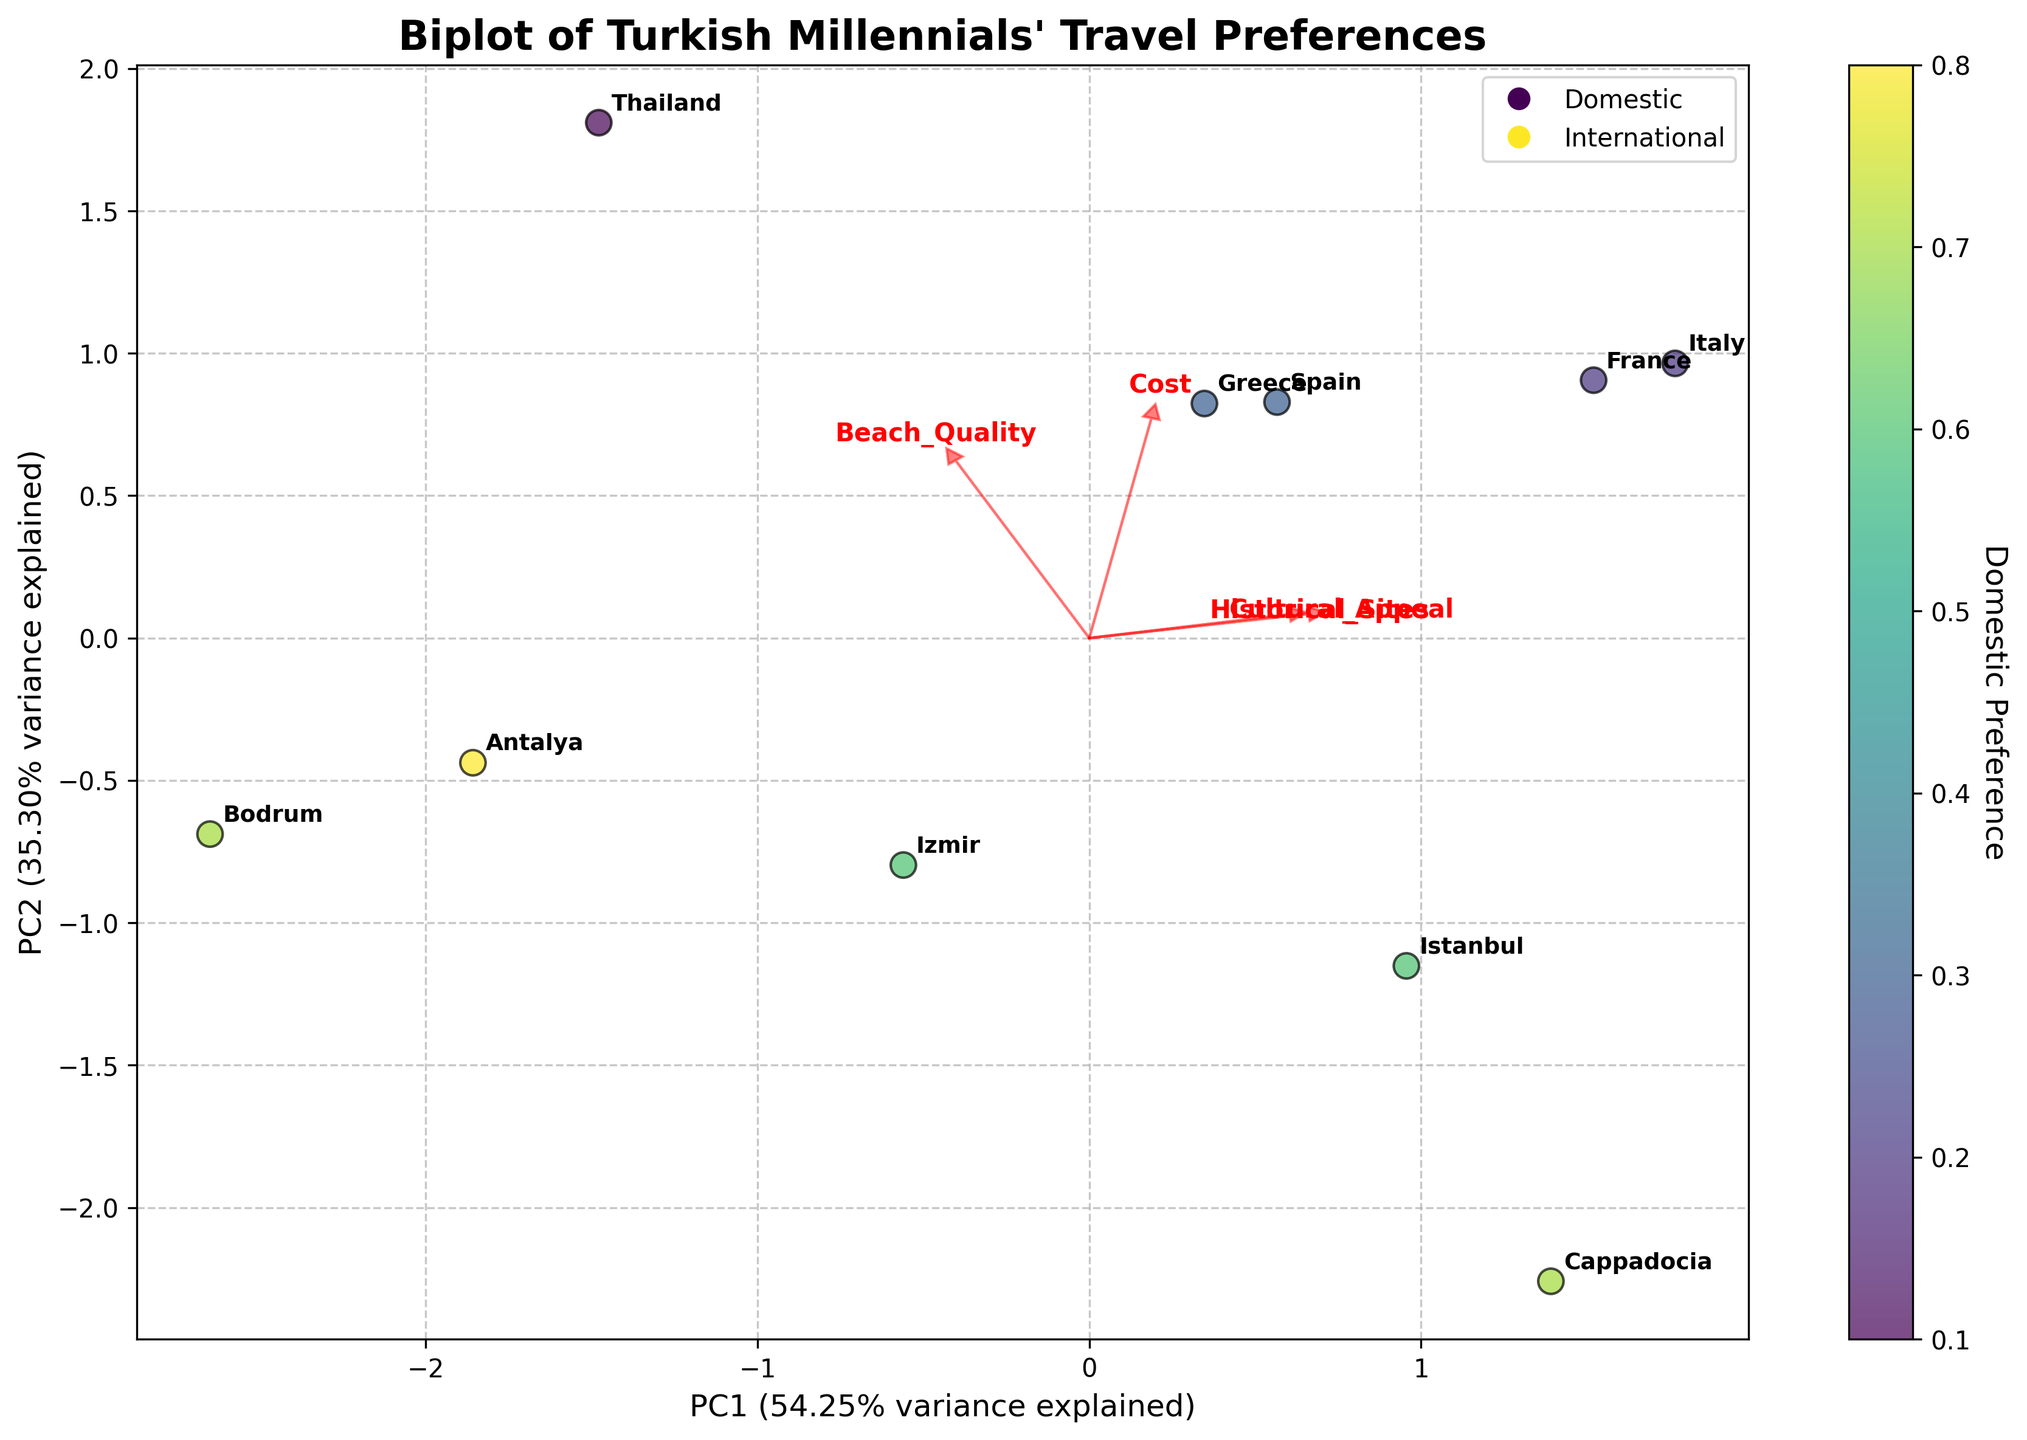What are the titles of the x and y axes? The x-axis title reads 'PC1' displaying the percentage variance explained, and the y-axis title reads 'PC2' displaying the percentage variance explained. This can be seen at the bottom and the side of the plot, respectively.
Answer: PC1, PC2 What destination has the highest value on the first principal component (PC1)? By looking at the scatterplot points on the x-axis, the point furthest to the right represents the highest value on the first principal component. This corresponds to Thailand.
Answer: Thailand Which feature vector points most directly towards historical sites? A red arrow that points almost directly upwards represents 'Historical_Sites'. This indicates that historical sites have a strong loading on PC2.
Answer: Historical_Sites Which destination has the lowest domestic preference? In the scatter plot with varying colors representing domestic preference, Thailand shows a predominantly yellow color, indicating the lowest domestic preference of 0.1.
Answer: Thailand What feature is negatively correlated with the cost according to the biplot? The feature vectors that point in nearly opposite directions from the 'Cost' vector indicate negative correlations. 'Beach_Quality' appears to be in the opposite direction to 'Cost'.
Answer: Beach_Quality Which destination is closest to the vector pointer for cultural appeal? Cappadocia is the closest destination point to the vector representing 'Cultural_Appeal', which points towards the top right.
Answer: Cappadocia Which side of the plot predominantly represents international destinations? International destinations are clustered towards the left side of the plot, indicated by lower values on the x-axis. Notably, Italy, Spain, and France are seen on the left.
Answer: Left side What percentage of the variance is explained by the first principal component (PC1)? The title near the x-axis specifies the percentage of explained variance. It shows that PC1 explains around 57.2% of the variance.
Answer: 57.2% Is the variance explained by PC2 greater than PC1? By observing the titles of PC1 and PC2, we can see their explained variance percentages. PC1 explains 57.2% while PC2 explains less at 26.4%. Thus, PC2 explains less variance than PC1.
Answer: No How do cultural appeal and historical sites relate according to the plot? The arrows representing 'Cultural_Appeal' and 'Historical_Sites' point in nearly the same direction. This indicates a strong positive correlation between these two features.
Answer: Positively correlated 